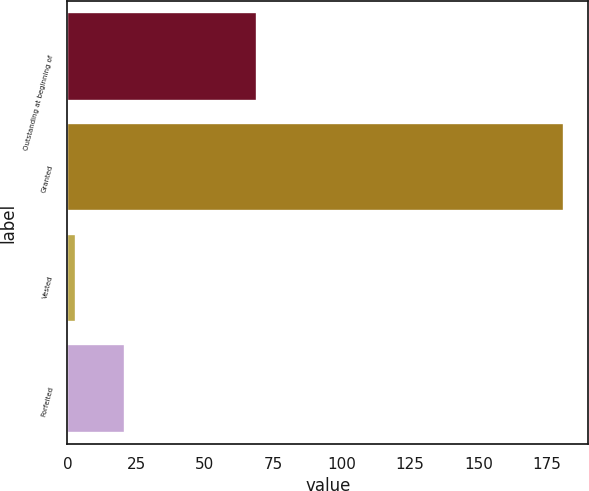<chart> <loc_0><loc_0><loc_500><loc_500><bar_chart><fcel>Outstanding at beginning of<fcel>Granted<fcel>Vested<fcel>Forfeited<nl><fcel>69<fcel>181<fcel>3<fcel>20.8<nl></chart> 